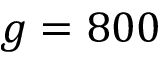Convert formula to latex. <formula><loc_0><loc_0><loc_500><loc_500>g = 8 0 0</formula> 